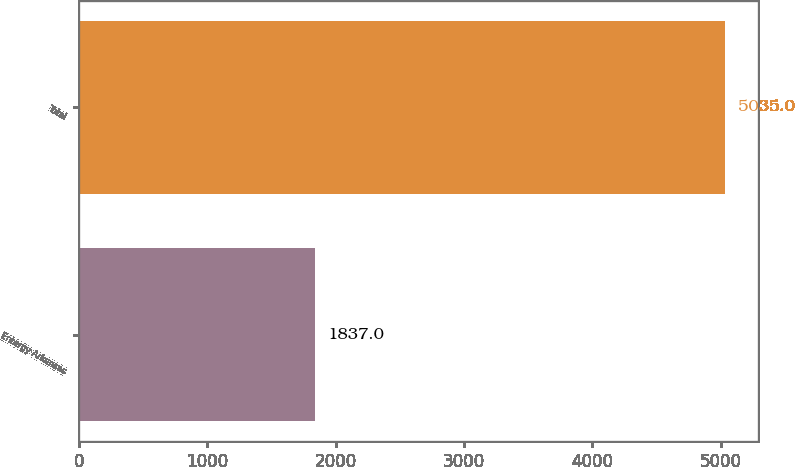Convert chart. <chart><loc_0><loc_0><loc_500><loc_500><bar_chart><fcel>Entergy Arkansas<fcel>Total<nl><fcel>1837<fcel>5035<nl></chart> 